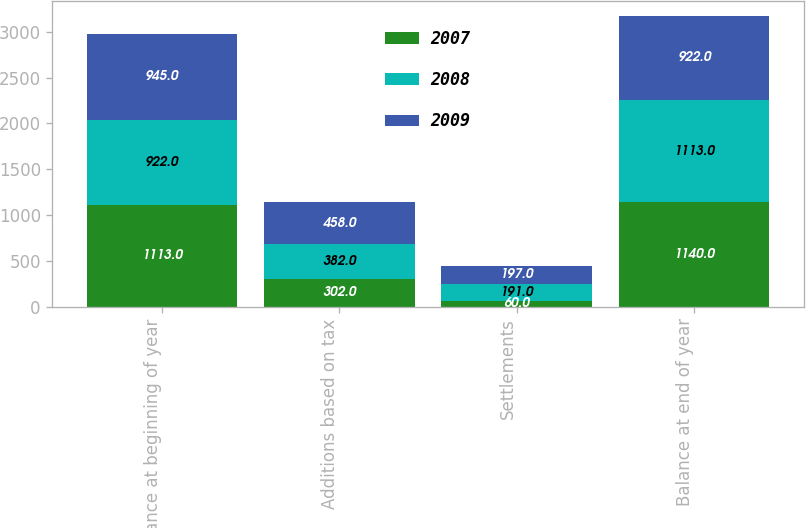Convert chart to OTSL. <chart><loc_0><loc_0><loc_500><loc_500><stacked_bar_chart><ecel><fcel>Balance at beginning of year<fcel>Additions based on tax<fcel>Settlements<fcel>Balance at end of year<nl><fcel>2007<fcel>1113<fcel>302<fcel>60<fcel>1140<nl><fcel>2008<fcel>922<fcel>382<fcel>191<fcel>1113<nl><fcel>2009<fcel>945<fcel>458<fcel>197<fcel>922<nl></chart> 